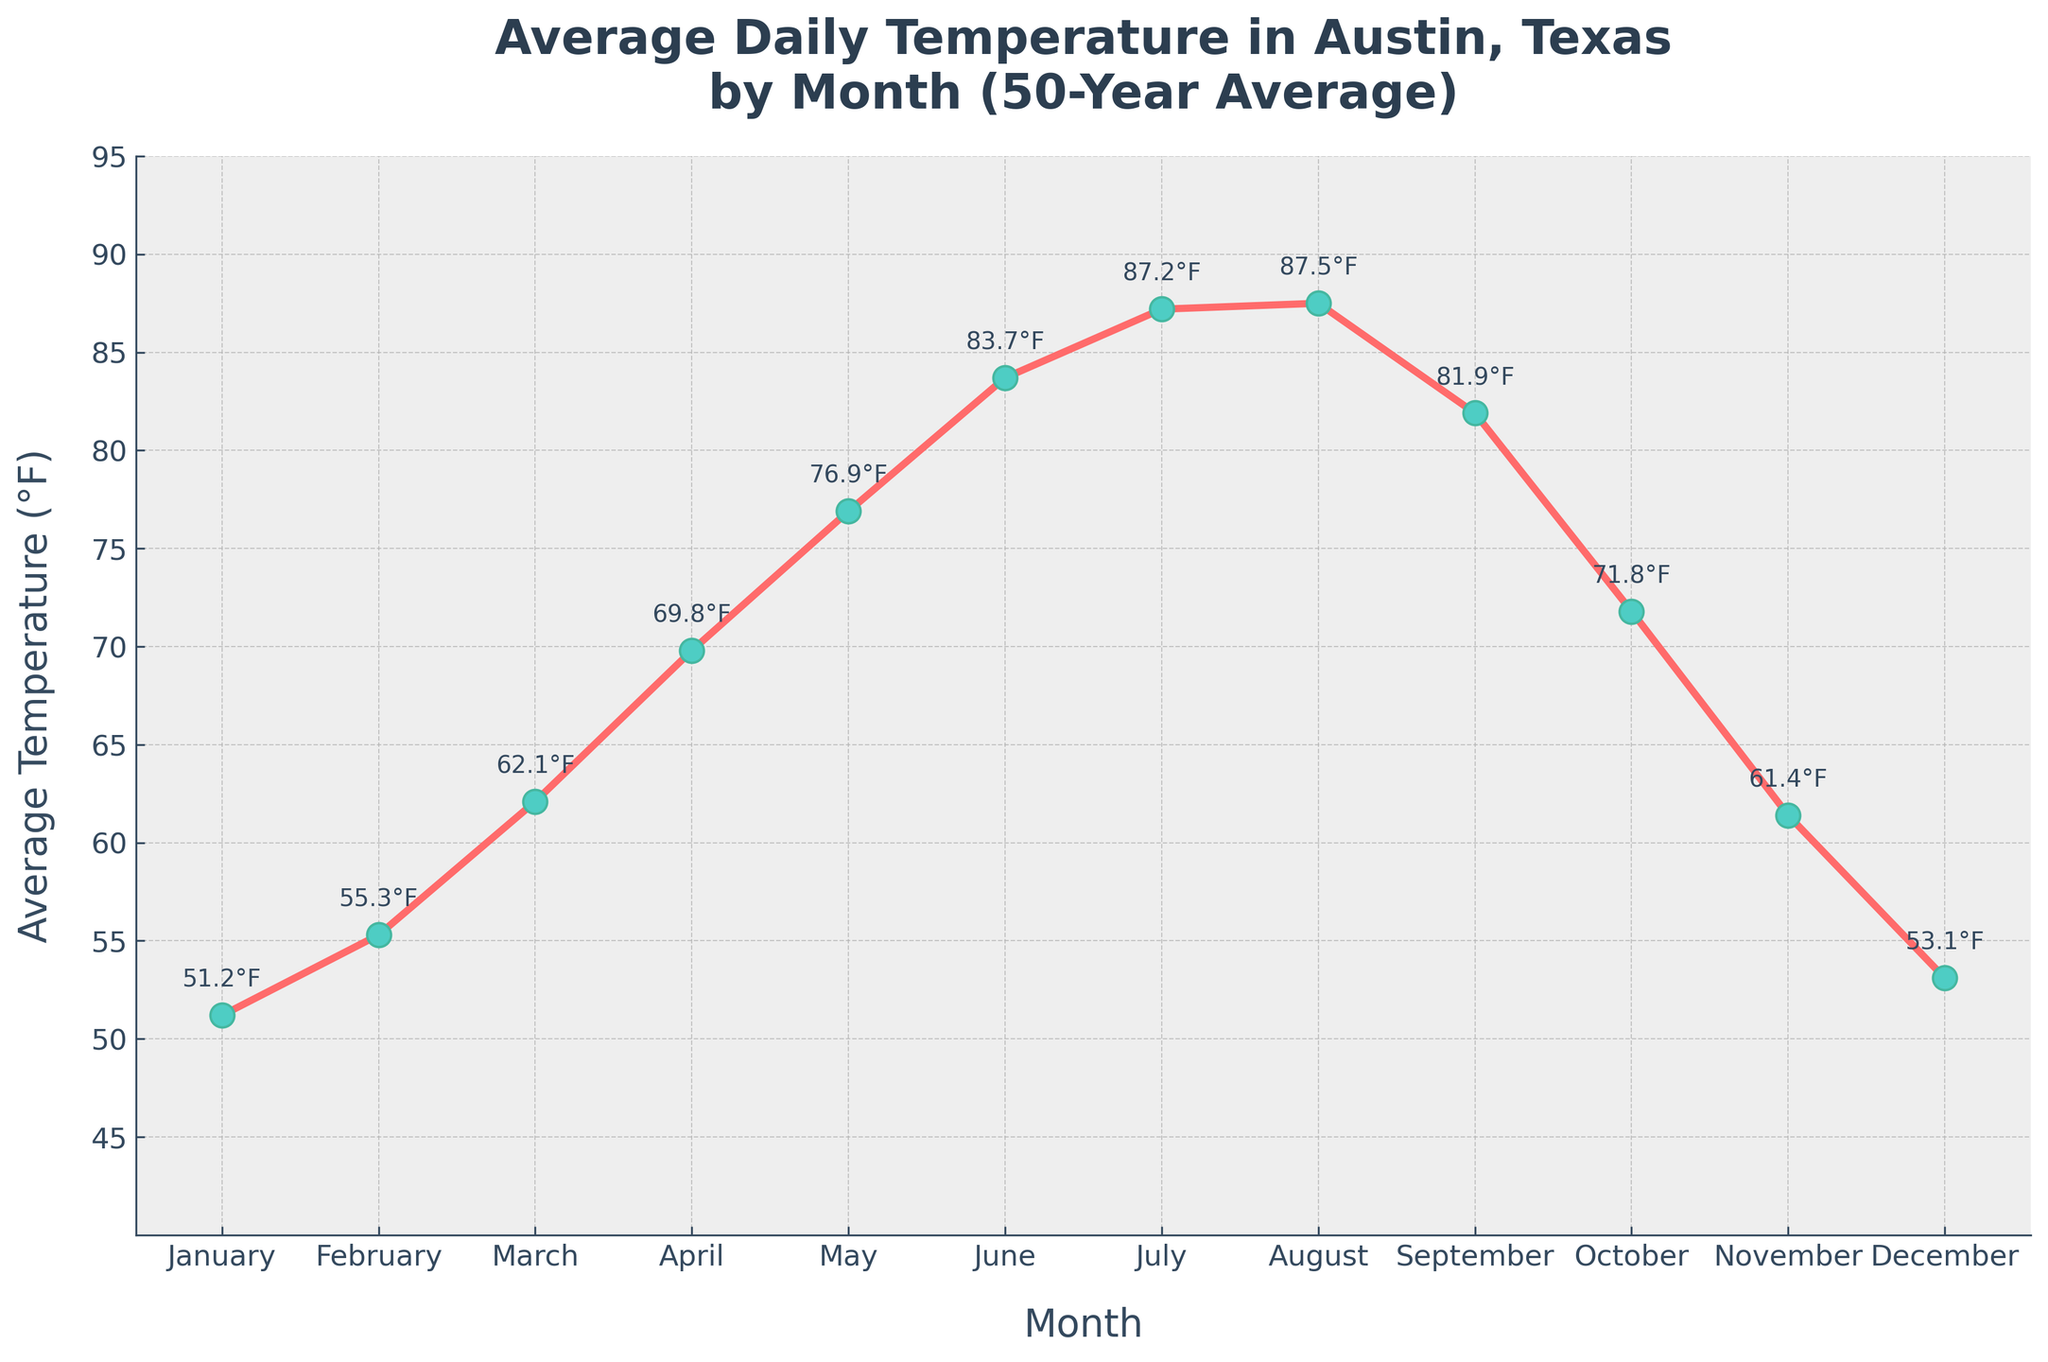What's the average temperature in July? From the figure, we can see the temperature for July marked as 87.2°F.
Answer: 87.2°F Which month has the highest average temperature? By inspecting the figure, we can see that the highest point is in August at 87.5°F.
Answer: August What is the temperature difference between the hottest month and the coldest month? The hottest month is August with 87.5°F and the coldest is January with 51.2°F. The difference is calculated as 87.5°F - 51.2°F = 36.3°F.
Answer: 36.3°F Which months have average temperatures below 60°F? By examining the y-axis, the only months where the temperature markers are below 60°F are January and December.
Answer: January, December In which month does the temperature first exceed 70°F? By following the temperature progression in the figure, we see that temperatures first exceed 70°F in April, where the temperature is 69.8°F, and then in May, it reaches 76.9°F.
Answer: May Is there any month where the average temperature is equal to 70°F? By examining the figure, we see there is no month where the average temperature is exactly 70°F. The closest is April at 69.8°F.
Answer: No Does the temperature increase or decrease from October to November? From the figure, it's clear that the temperature decreases from October (71.8°F) to November (61.4°F).
Answer: Decrease What is the temperature range from June to September? From June (83.7°F) to September (81.9°F), the temperature ranges from 81.9°F to 87.5°F. So, the temperature range is 87.5°F - 81.9°F = 5.6°F.
Answer: 5.6°F Which month has the lowest average temperature? By examining the data points, January has the lowest temperature at 51.2°F.
Answer: January How many months have temperatures above 80°F? Checking the figure, June (83.7°F), July (87.2°F), August (87.5°F), and September (81.9°F), giving us a total of 4 months.
Answer: 4 